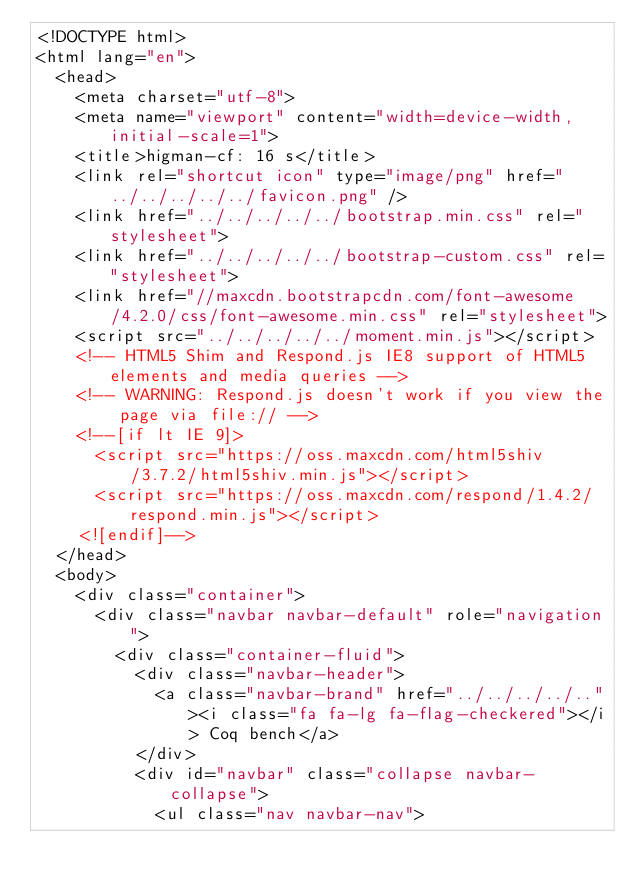Convert code to text. <code><loc_0><loc_0><loc_500><loc_500><_HTML_><!DOCTYPE html>
<html lang="en">
  <head>
    <meta charset="utf-8">
    <meta name="viewport" content="width=device-width, initial-scale=1">
    <title>higman-cf: 16 s</title>
    <link rel="shortcut icon" type="image/png" href="../../../../../favicon.png" />
    <link href="../../../../../bootstrap.min.css" rel="stylesheet">
    <link href="../../../../../bootstrap-custom.css" rel="stylesheet">
    <link href="//maxcdn.bootstrapcdn.com/font-awesome/4.2.0/css/font-awesome.min.css" rel="stylesheet">
    <script src="../../../../../moment.min.js"></script>
    <!-- HTML5 Shim and Respond.js IE8 support of HTML5 elements and media queries -->
    <!-- WARNING: Respond.js doesn't work if you view the page via file:// -->
    <!--[if lt IE 9]>
      <script src="https://oss.maxcdn.com/html5shiv/3.7.2/html5shiv.min.js"></script>
      <script src="https://oss.maxcdn.com/respond/1.4.2/respond.min.js"></script>
    <![endif]-->
  </head>
  <body>
    <div class="container">
      <div class="navbar navbar-default" role="navigation">
        <div class="container-fluid">
          <div class="navbar-header">
            <a class="navbar-brand" href="../../../../.."><i class="fa fa-lg fa-flag-checkered"></i> Coq bench</a>
          </div>
          <div id="navbar" class="collapse navbar-collapse">
            <ul class="nav navbar-nav"></code> 